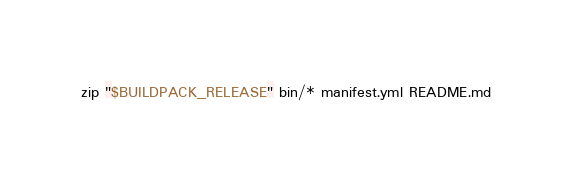Convert code to text. <code><loc_0><loc_0><loc_500><loc_500><_Bash_>
zip "$BUILDPACK_RELEASE" bin/* manifest.yml README.md
</code> 